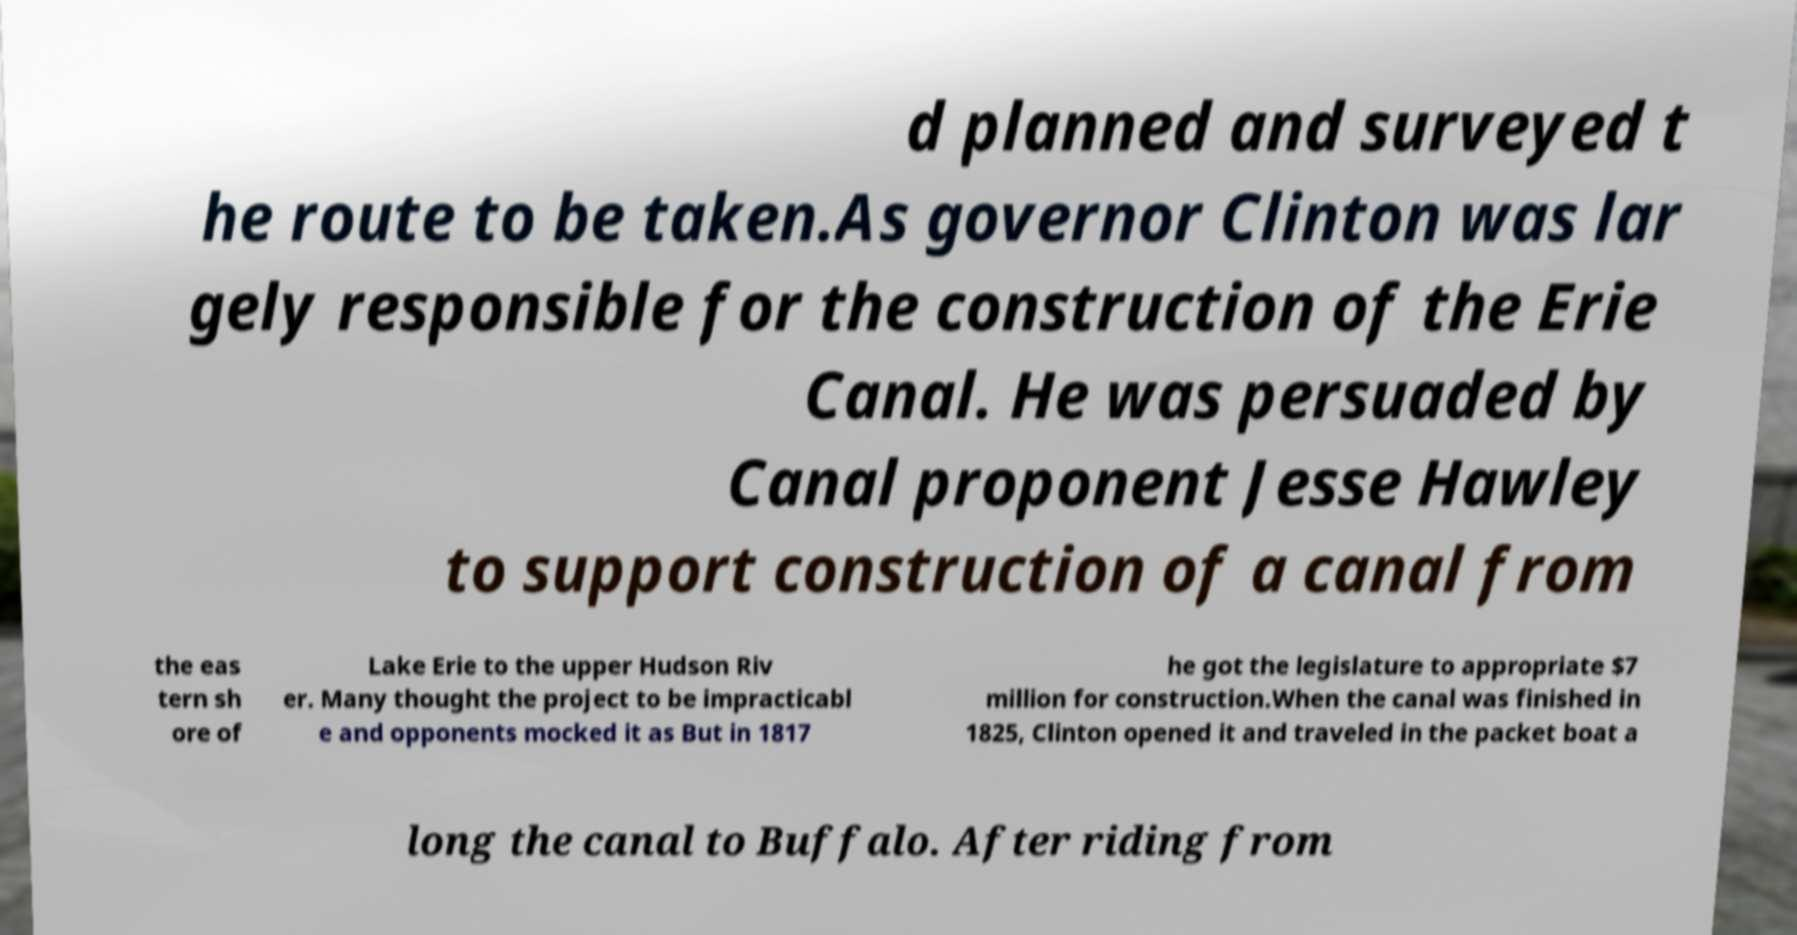Please identify and transcribe the text found in this image. d planned and surveyed t he route to be taken.As governor Clinton was lar gely responsible for the construction of the Erie Canal. He was persuaded by Canal proponent Jesse Hawley to support construction of a canal from the eas tern sh ore of Lake Erie to the upper Hudson Riv er. Many thought the project to be impracticabl e and opponents mocked it as But in 1817 he got the legislature to appropriate $7 million for construction.When the canal was finished in 1825, Clinton opened it and traveled in the packet boat a long the canal to Buffalo. After riding from 